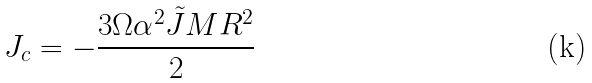<formula> <loc_0><loc_0><loc_500><loc_500>J _ { c } = - \frac { 3 \Omega \alpha ^ { 2 } \tilde { J } M R ^ { 2 } } { 2 }</formula> 